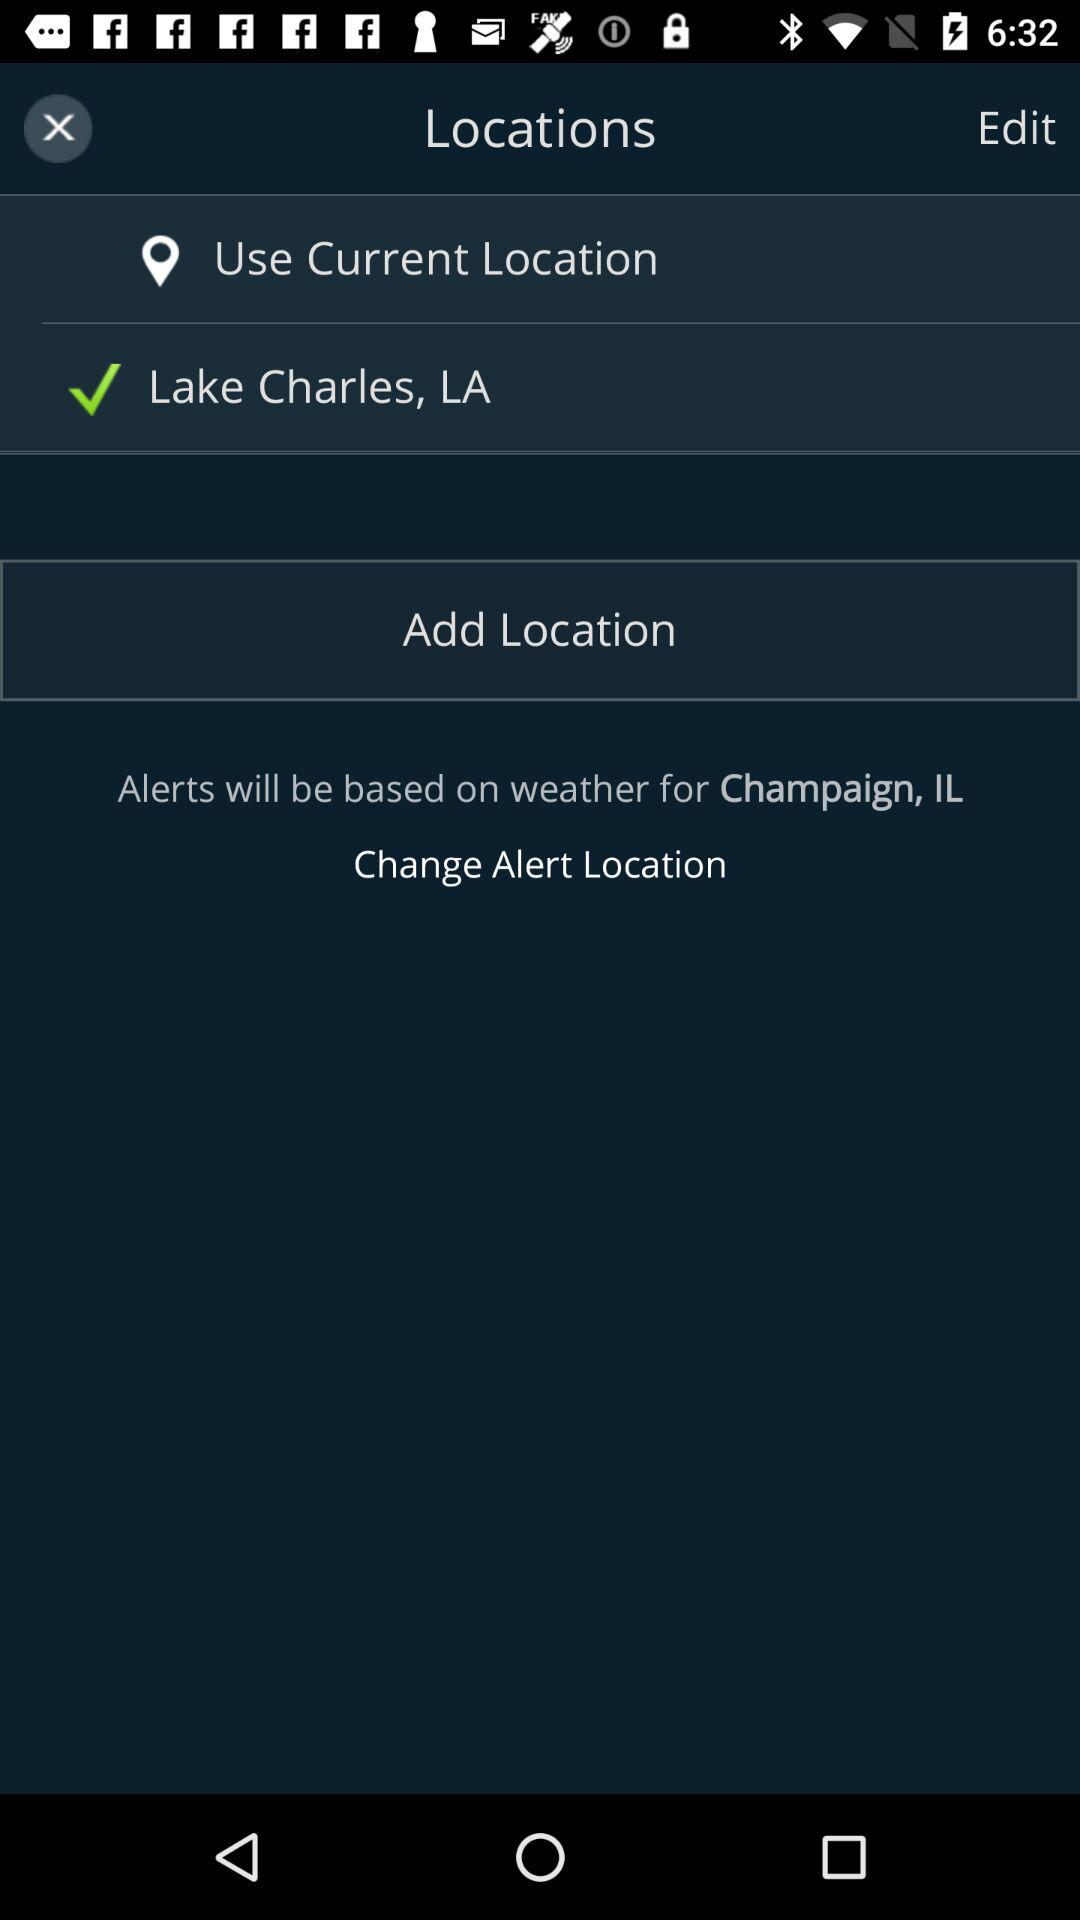How many locations are not the current location?
Answer the question using a single word or phrase. 1 